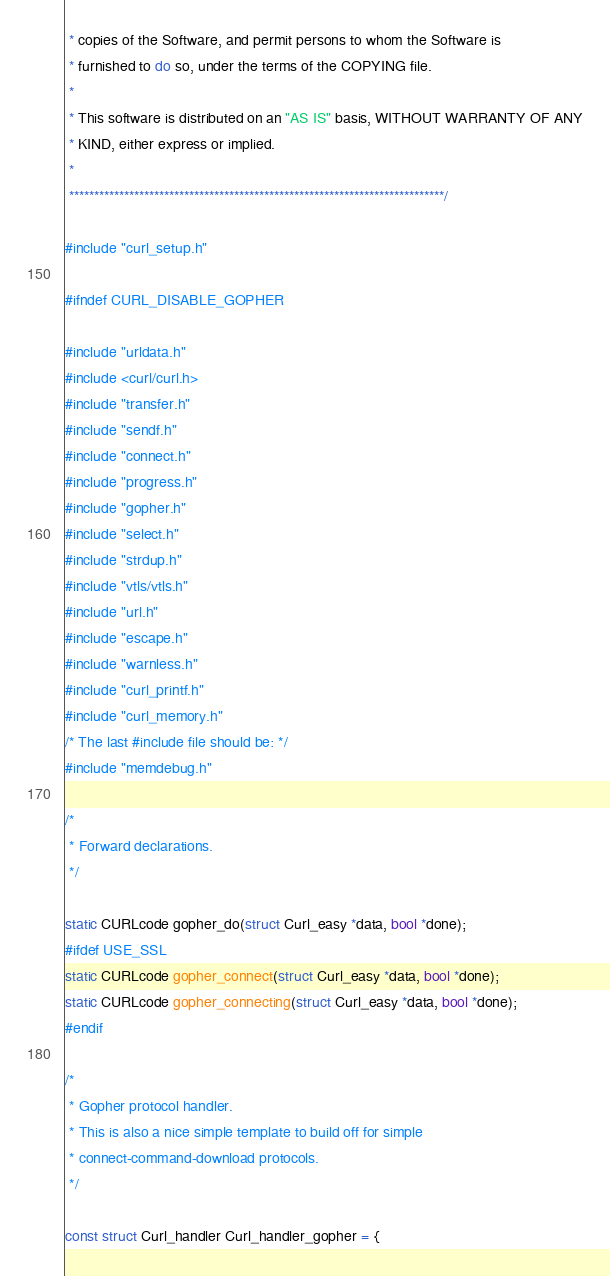Convert code to text. <code><loc_0><loc_0><loc_500><loc_500><_C_> * copies of the Software, and permit persons to whom the Software is
 * furnished to do so, under the terms of the COPYING file.
 *
 * This software is distributed on an "AS IS" basis, WITHOUT WARRANTY OF ANY
 * KIND, either express or implied.
 *
 ***************************************************************************/

#include "curl_setup.h"

#ifndef CURL_DISABLE_GOPHER

#include "urldata.h"
#include <curl/curl.h>
#include "transfer.h"
#include "sendf.h"
#include "connect.h"
#include "progress.h"
#include "gopher.h"
#include "select.h"
#include "strdup.h"
#include "vtls/vtls.h"
#include "url.h"
#include "escape.h"
#include "warnless.h"
#include "curl_printf.h"
#include "curl_memory.h"
/* The last #include file should be: */
#include "memdebug.h"

/*
 * Forward declarations.
 */

static CURLcode gopher_do(struct Curl_easy *data, bool *done);
#ifdef USE_SSL
static CURLcode gopher_connect(struct Curl_easy *data, bool *done);
static CURLcode gopher_connecting(struct Curl_easy *data, bool *done);
#endif

/*
 * Gopher protocol handler.
 * This is also a nice simple template to build off for simple
 * connect-command-download protocols.
 */

const struct Curl_handler Curl_handler_gopher = {</code> 